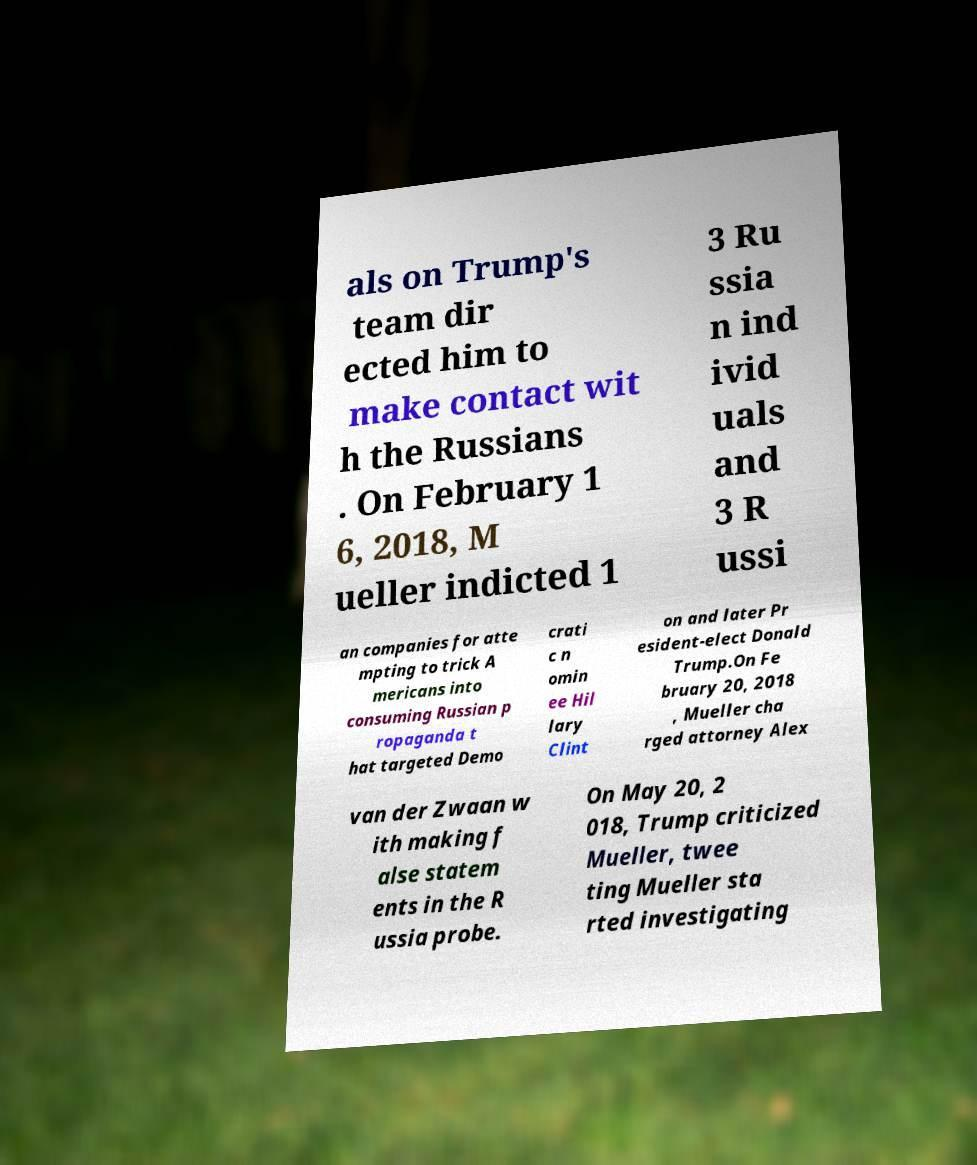Can you read and provide the text displayed in the image?This photo seems to have some interesting text. Can you extract and type it out for me? als on Trump's team dir ected him to make contact wit h the Russians . On February 1 6, 2018, M ueller indicted 1 3 Ru ssia n ind ivid uals and 3 R ussi an companies for atte mpting to trick A mericans into consuming Russian p ropaganda t hat targeted Demo crati c n omin ee Hil lary Clint on and later Pr esident-elect Donald Trump.On Fe bruary 20, 2018 , Mueller cha rged attorney Alex van der Zwaan w ith making f alse statem ents in the R ussia probe. On May 20, 2 018, Trump criticized Mueller, twee ting Mueller sta rted investigating 